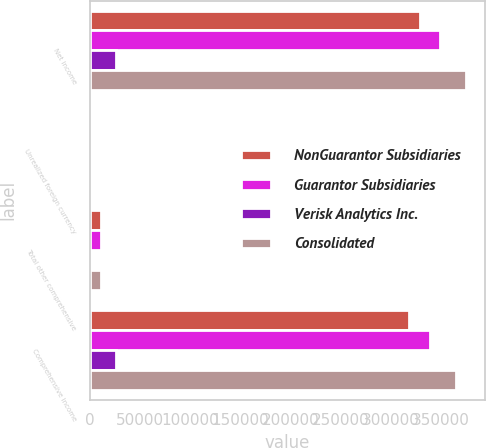Convert chart to OTSL. <chart><loc_0><loc_0><loc_500><loc_500><stacked_bar_chart><ecel><fcel>Net income<fcel>Unrealized foreign currency<fcel>Total other comprehensive<fcel>Comprehensive income<nl><fcel>NonGuarantor Subsidiaries<fcel>329142<fcel>15<fcel>10873<fcel>318269<nl><fcel>Guarantor Subsidiaries<fcel>349309<fcel>172<fcel>10716<fcel>338593<nl><fcel>Verisk Analytics Inc.<fcel>25963<fcel>46<fcel>46<fcel>26009<nl><fcel>Consolidated<fcel>375272<fcel>218<fcel>10670<fcel>364602<nl></chart> 